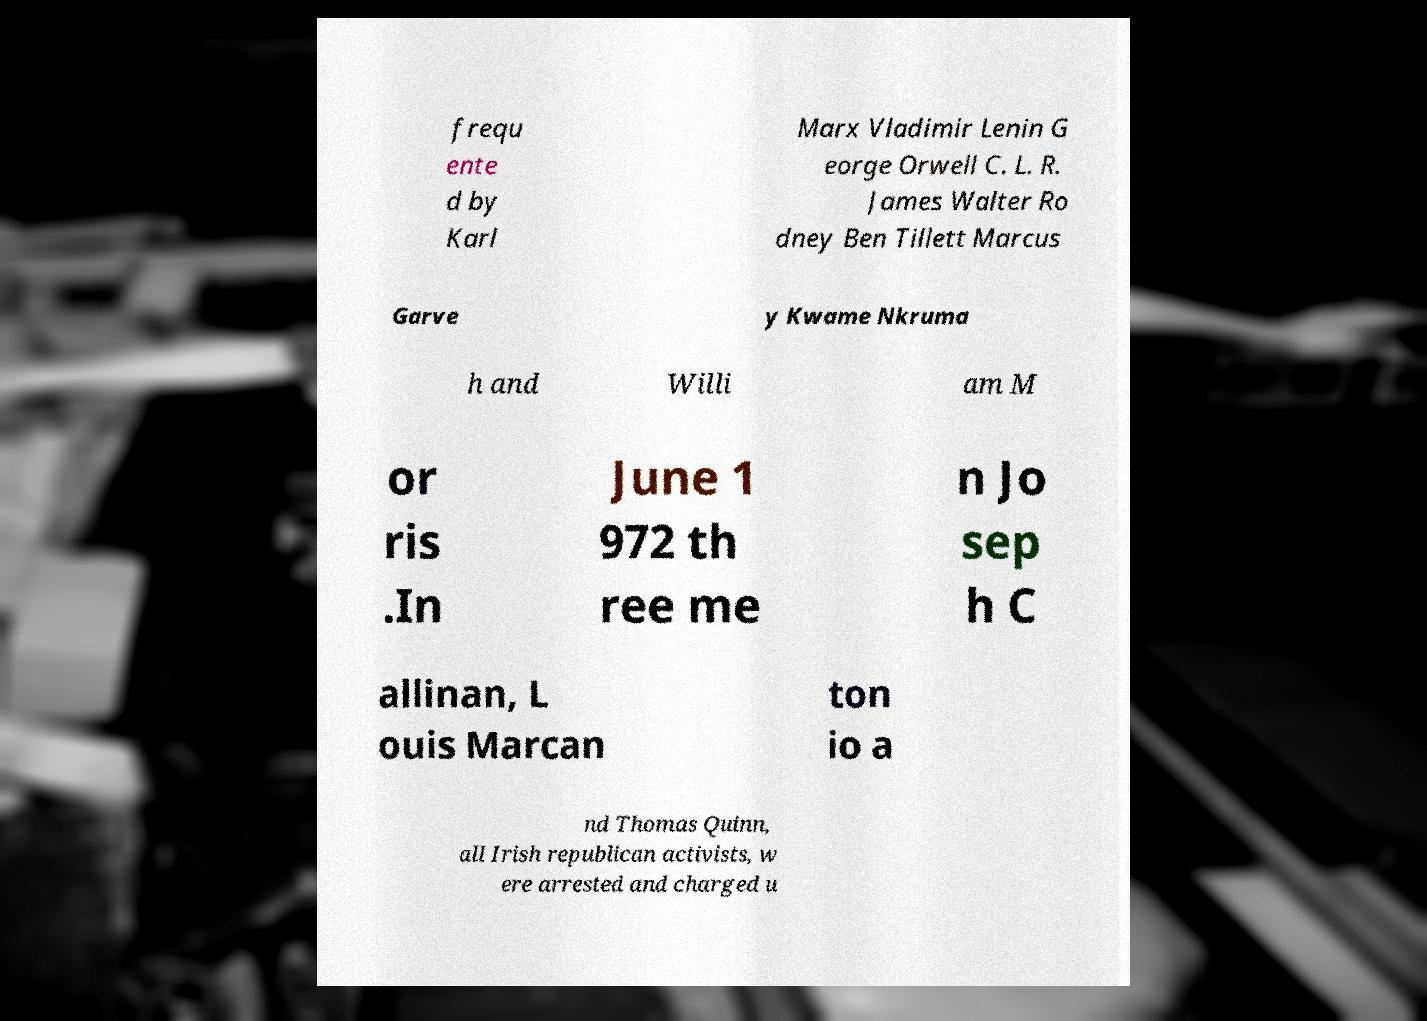Could you assist in decoding the text presented in this image and type it out clearly? frequ ente d by Karl Marx Vladimir Lenin G eorge Orwell C. L. R. James Walter Ro dney Ben Tillett Marcus Garve y Kwame Nkruma h and Willi am M or ris .In June 1 972 th ree me n Jo sep h C allinan, L ouis Marcan ton io a nd Thomas Quinn, all Irish republican activists, w ere arrested and charged u 